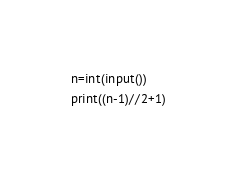<code> <loc_0><loc_0><loc_500><loc_500><_Python_>n=int(input())
print((n-1)//2+1)</code> 